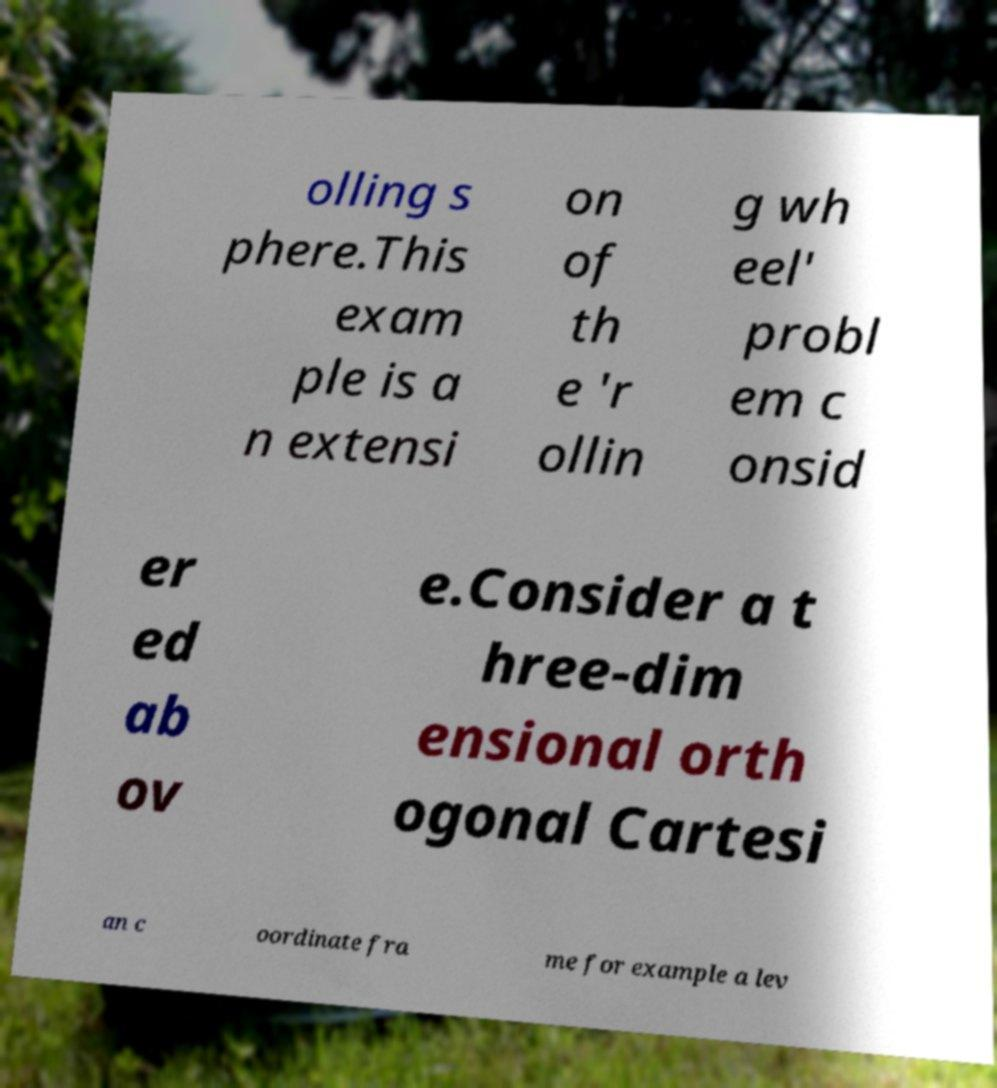Could you extract and type out the text from this image? olling s phere.This exam ple is a n extensi on of th e 'r ollin g wh eel' probl em c onsid er ed ab ov e.Consider a t hree-dim ensional orth ogonal Cartesi an c oordinate fra me for example a lev 